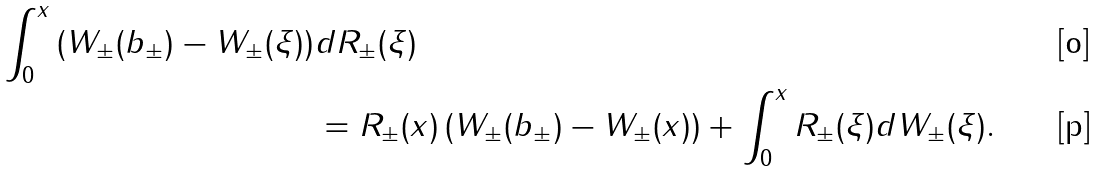Convert formula to latex. <formula><loc_0><loc_0><loc_500><loc_500>\int _ { 0 } ^ { x } \left ( W _ { \pm } ( b _ { \pm } ) - W _ { \pm } ( \xi ) \right ) & d R _ { \pm } ( \xi ) \\ & = R _ { \pm } ( x ) \left ( W _ { \pm } ( b _ { \pm } ) - W _ { \pm } ( x ) \right ) + \int _ { 0 } ^ { x } R _ { \pm } ( \xi ) d W _ { \pm } ( \xi ) .</formula> 